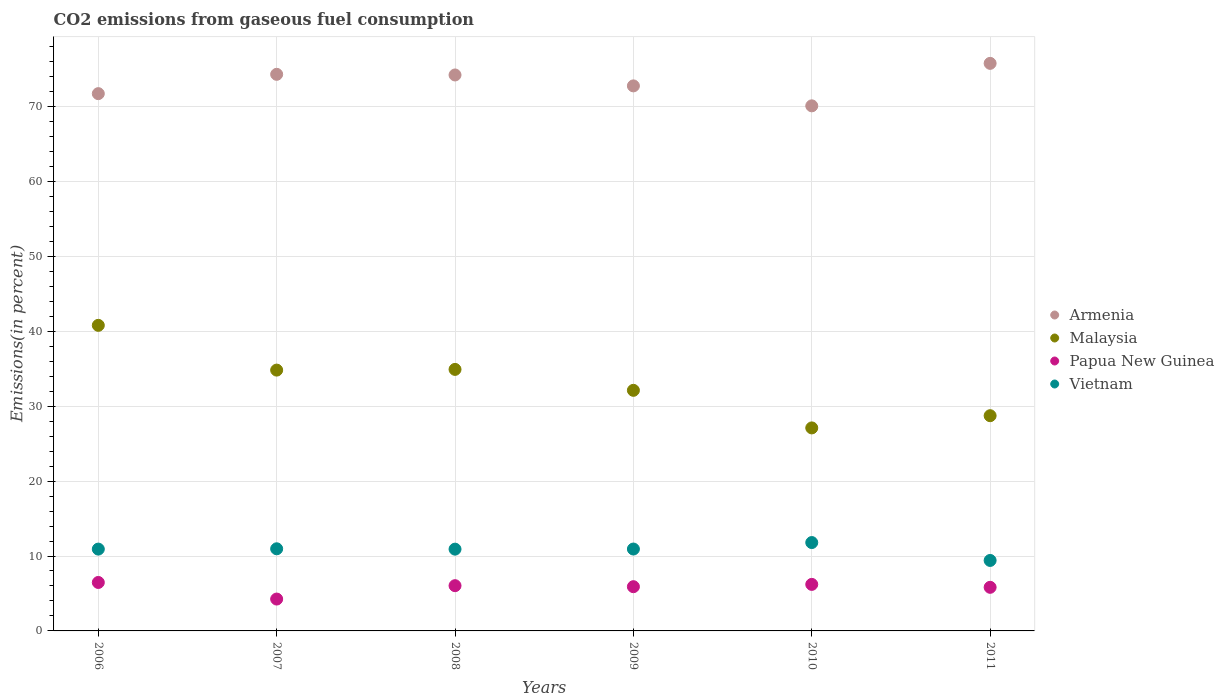Is the number of dotlines equal to the number of legend labels?
Ensure brevity in your answer.  Yes. What is the total CO2 emitted in Armenia in 2009?
Offer a very short reply. 72.75. Across all years, what is the maximum total CO2 emitted in Vietnam?
Your answer should be compact. 11.79. Across all years, what is the minimum total CO2 emitted in Vietnam?
Offer a very short reply. 9.41. What is the total total CO2 emitted in Vietnam in the graph?
Provide a succinct answer. 64.93. What is the difference between the total CO2 emitted in Vietnam in 2010 and that in 2011?
Your answer should be compact. 2.39. What is the difference between the total CO2 emitted in Vietnam in 2007 and the total CO2 emitted in Papua New Guinea in 2008?
Provide a short and direct response. 4.92. What is the average total CO2 emitted in Vietnam per year?
Your response must be concise. 10.82. In the year 2011, what is the difference between the total CO2 emitted in Vietnam and total CO2 emitted in Armenia?
Provide a succinct answer. -66.35. What is the ratio of the total CO2 emitted in Papua New Guinea in 2010 to that in 2011?
Your answer should be very brief. 1.07. Is the difference between the total CO2 emitted in Vietnam in 2006 and 2011 greater than the difference between the total CO2 emitted in Armenia in 2006 and 2011?
Give a very brief answer. Yes. What is the difference between the highest and the second highest total CO2 emitted in Armenia?
Ensure brevity in your answer.  1.46. What is the difference between the highest and the lowest total CO2 emitted in Papua New Guinea?
Provide a short and direct response. 2.21. Is the sum of the total CO2 emitted in Papua New Guinea in 2006 and 2009 greater than the maximum total CO2 emitted in Malaysia across all years?
Provide a short and direct response. No. Is it the case that in every year, the sum of the total CO2 emitted in Papua New Guinea and total CO2 emitted in Armenia  is greater than the total CO2 emitted in Vietnam?
Your answer should be compact. Yes. Does the total CO2 emitted in Armenia monotonically increase over the years?
Provide a succinct answer. No. Is the total CO2 emitted in Papua New Guinea strictly less than the total CO2 emitted in Vietnam over the years?
Offer a very short reply. Yes. How many years are there in the graph?
Give a very brief answer. 6. What is the difference between two consecutive major ticks on the Y-axis?
Offer a very short reply. 10. Does the graph contain any zero values?
Keep it short and to the point. No. How many legend labels are there?
Your answer should be compact. 4. What is the title of the graph?
Keep it short and to the point. CO2 emissions from gaseous fuel consumption. Does "Low income" appear as one of the legend labels in the graph?
Give a very brief answer. No. What is the label or title of the Y-axis?
Make the answer very short. Emissions(in percent). What is the Emissions(in percent) of Armenia in 2006?
Your answer should be compact. 71.72. What is the Emissions(in percent) in Malaysia in 2006?
Your answer should be compact. 40.79. What is the Emissions(in percent) in Papua New Guinea in 2006?
Your answer should be compact. 6.47. What is the Emissions(in percent) of Vietnam in 2006?
Give a very brief answer. 10.92. What is the Emissions(in percent) of Armenia in 2007?
Keep it short and to the point. 74.29. What is the Emissions(in percent) in Malaysia in 2007?
Provide a succinct answer. 34.81. What is the Emissions(in percent) of Papua New Guinea in 2007?
Provide a short and direct response. 4.25. What is the Emissions(in percent) of Vietnam in 2007?
Your answer should be compact. 10.96. What is the Emissions(in percent) of Armenia in 2008?
Your response must be concise. 74.21. What is the Emissions(in percent) in Malaysia in 2008?
Provide a succinct answer. 34.91. What is the Emissions(in percent) of Papua New Guinea in 2008?
Keep it short and to the point. 6.04. What is the Emissions(in percent) of Vietnam in 2008?
Offer a terse response. 10.91. What is the Emissions(in percent) of Armenia in 2009?
Ensure brevity in your answer.  72.75. What is the Emissions(in percent) of Malaysia in 2009?
Give a very brief answer. 32.11. What is the Emissions(in percent) of Papua New Guinea in 2009?
Give a very brief answer. 5.9. What is the Emissions(in percent) in Vietnam in 2009?
Keep it short and to the point. 10.93. What is the Emissions(in percent) in Armenia in 2010?
Offer a very short reply. 70.09. What is the Emissions(in percent) in Malaysia in 2010?
Offer a very short reply. 27.1. What is the Emissions(in percent) of Papua New Guinea in 2010?
Make the answer very short. 6.21. What is the Emissions(in percent) in Vietnam in 2010?
Your answer should be very brief. 11.79. What is the Emissions(in percent) of Armenia in 2011?
Your response must be concise. 75.76. What is the Emissions(in percent) in Malaysia in 2011?
Your answer should be compact. 28.73. What is the Emissions(in percent) of Papua New Guinea in 2011?
Offer a terse response. 5.82. What is the Emissions(in percent) of Vietnam in 2011?
Your response must be concise. 9.41. Across all years, what is the maximum Emissions(in percent) in Armenia?
Your answer should be compact. 75.76. Across all years, what is the maximum Emissions(in percent) of Malaysia?
Your answer should be very brief. 40.79. Across all years, what is the maximum Emissions(in percent) in Papua New Guinea?
Give a very brief answer. 6.47. Across all years, what is the maximum Emissions(in percent) in Vietnam?
Make the answer very short. 11.79. Across all years, what is the minimum Emissions(in percent) in Armenia?
Your answer should be very brief. 70.09. Across all years, what is the minimum Emissions(in percent) of Malaysia?
Provide a succinct answer. 27.1. Across all years, what is the minimum Emissions(in percent) in Papua New Guinea?
Give a very brief answer. 4.25. Across all years, what is the minimum Emissions(in percent) of Vietnam?
Keep it short and to the point. 9.41. What is the total Emissions(in percent) in Armenia in the graph?
Your response must be concise. 438.81. What is the total Emissions(in percent) of Malaysia in the graph?
Your answer should be very brief. 198.45. What is the total Emissions(in percent) of Papua New Guinea in the graph?
Give a very brief answer. 34.7. What is the total Emissions(in percent) in Vietnam in the graph?
Offer a very short reply. 64.93. What is the difference between the Emissions(in percent) of Armenia in 2006 and that in 2007?
Provide a succinct answer. -2.58. What is the difference between the Emissions(in percent) in Malaysia in 2006 and that in 2007?
Your response must be concise. 5.97. What is the difference between the Emissions(in percent) of Papua New Guinea in 2006 and that in 2007?
Make the answer very short. 2.21. What is the difference between the Emissions(in percent) of Vietnam in 2006 and that in 2007?
Your answer should be compact. -0.04. What is the difference between the Emissions(in percent) of Armenia in 2006 and that in 2008?
Provide a short and direct response. -2.49. What is the difference between the Emissions(in percent) in Malaysia in 2006 and that in 2008?
Provide a succinct answer. 5.88. What is the difference between the Emissions(in percent) of Papua New Guinea in 2006 and that in 2008?
Offer a terse response. 0.43. What is the difference between the Emissions(in percent) of Vietnam in 2006 and that in 2008?
Provide a succinct answer. 0.01. What is the difference between the Emissions(in percent) in Armenia in 2006 and that in 2009?
Offer a very short reply. -1.03. What is the difference between the Emissions(in percent) in Malaysia in 2006 and that in 2009?
Your answer should be compact. 8.67. What is the difference between the Emissions(in percent) of Papua New Guinea in 2006 and that in 2009?
Provide a short and direct response. 0.56. What is the difference between the Emissions(in percent) in Vietnam in 2006 and that in 2009?
Your answer should be compact. -0.01. What is the difference between the Emissions(in percent) of Armenia in 2006 and that in 2010?
Provide a succinct answer. 1.63. What is the difference between the Emissions(in percent) in Malaysia in 2006 and that in 2010?
Keep it short and to the point. 13.69. What is the difference between the Emissions(in percent) in Papua New Guinea in 2006 and that in 2010?
Offer a terse response. 0.26. What is the difference between the Emissions(in percent) in Vietnam in 2006 and that in 2010?
Offer a terse response. -0.87. What is the difference between the Emissions(in percent) of Armenia in 2006 and that in 2011?
Offer a very short reply. -4.04. What is the difference between the Emissions(in percent) in Malaysia in 2006 and that in 2011?
Your answer should be very brief. 12.06. What is the difference between the Emissions(in percent) of Papua New Guinea in 2006 and that in 2011?
Offer a terse response. 0.65. What is the difference between the Emissions(in percent) of Vietnam in 2006 and that in 2011?
Your answer should be compact. 1.51. What is the difference between the Emissions(in percent) of Armenia in 2007 and that in 2008?
Make the answer very short. 0.09. What is the difference between the Emissions(in percent) in Malaysia in 2007 and that in 2008?
Make the answer very short. -0.09. What is the difference between the Emissions(in percent) of Papua New Guinea in 2007 and that in 2008?
Offer a very short reply. -1.79. What is the difference between the Emissions(in percent) in Vietnam in 2007 and that in 2008?
Give a very brief answer. 0.05. What is the difference between the Emissions(in percent) in Armenia in 2007 and that in 2009?
Offer a very short reply. 1.54. What is the difference between the Emissions(in percent) in Malaysia in 2007 and that in 2009?
Your answer should be very brief. 2.7. What is the difference between the Emissions(in percent) in Papua New Guinea in 2007 and that in 2009?
Offer a terse response. -1.65. What is the difference between the Emissions(in percent) in Vietnam in 2007 and that in 2009?
Provide a succinct answer. 0.03. What is the difference between the Emissions(in percent) of Armenia in 2007 and that in 2010?
Your answer should be very brief. 4.21. What is the difference between the Emissions(in percent) of Malaysia in 2007 and that in 2010?
Provide a succinct answer. 7.72. What is the difference between the Emissions(in percent) in Papua New Guinea in 2007 and that in 2010?
Provide a short and direct response. -1.96. What is the difference between the Emissions(in percent) in Vietnam in 2007 and that in 2010?
Make the answer very short. -0.83. What is the difference between the Emissions(in percent) in Armenia in 2007 and that in 2011?
Your answer should be very brief. -1.46. What is the difference between the Emissions(in percent) of Malaysia in 2007 and that in 2011?
Your answer should be compact. 6.09. What is the difference between the Emissions(in percent) of Papua New Guinea in 2007 and that in 2011?
Your answer should be very brief. -1.57. What is the difference between the Emissions(in percent) of Vietnam in 2007 and that in 2011?
Give a very brief answer. 1.56. What is the difference between the Emissions(in percent) in Armenia in 2008 and that in 2009?
Keep it short and to the point. 1.46. What is the difference between the Emissions(in percent) in Malaysia in 2008 and that in 2009?
Keep it short and to the point. 2.79. What is the difference between the Emissions(in percent) in Papua New Guinea in 2008 and that in 2009?
Make the answer very short. 0.14. What is the difference between the Emissions(in percent) of Vietnam in 2008 and that in 2009?
Make the answer very short. -0.02. What is the difference between the Emissions(in percent) of Armenia in 2008 and that in 2010?
Give a very brief answer. 4.12. What is the difference between the Emissions(in percent) of Malaysia in 2008 and that in 2010?
Offer a terse response. 7.81. What is the difference between the Emissions(in percent) of Papua New Guinea in 2008 and that in 2010?
Your answer should be very brief. -0.17. What is the difference between the Emissions(in percent) in Vietnam in 2008 and that in 2010?
Offer a very short reply. -0.88. What is the difference between the Emissions(in percent) of Armenia in 2008 and that in 2011?
Keep it short and to the point. -1.55. What is the difference between the Emissions(in percent) of Malaysia in 2008 and that in 2011?
Keep it short and to the point. 6.18. What is the difference between the Emissions(in percent) in Papua New Guinea in 2008 and that in 2011?
Offer a very short reply. 0.22. What is the difference between the Emissions(in percent) of Vietnam in 2008 and that in 2011?
Ensure brevity in your answer.  1.51. What is the difference between the Emissions(in percent) in Armenia in 2009 and that in 2010?
Your answer should be compact. 2.66. What is the difference between the Emissions(in percent) of Malaysia in 2009 and that in 2010?
Ensure brevity in your answer.  5.02. What is the difference between the Emissions(in percent) of Papua New Guinea in 2009 and that in 2010?
Offer a terse response. -0.31. What is the difference between the Emissions(in percent) of Vietnam in 2009 and that in 2010?
Provide a short and direct response. -0.86. What is the difference between the Emissions(in percent) of Armenia in 2009 and that in 2011?
Give a very brief answer. -3.01. What is the difference between the Emissions(in percent) of Malaysia in 2009 and that in 2011?
Make the answer very short. 3.39. What is the difference between the Emissions(in percent) in Papua New Guinea in 2009 and that in 2011?
Your answer should be very brief. 0.08. What is the difference between the Emissions(in percent) of Vietnam in 2009 and that in 2011?
Ensure brevity in your answer.  1.52. What is the difference between the Emissions(in percent) of Armenia in 2010 and that in 2011?
Ensure brevity in your answer.  -5.67. What is the difference between the Emissions(in percent) of Malaysia in 2010 and that in 2011?
Keep it short and to the point. -1.63. What is the difference between the Emissions(in percent) of Papua New Guinea in 2010 and that in 2011?
Your answer should be compact. 0.39. What is the difference between the Emissions(in percent) in Vietnam in 2010 and that in 2011?
Provide a succinct answer. 2.39. What is the difference between the Emissions(in percent) in Armenia in 2006 and the Emissions(in percent) in Malaysia in 2007?
Provide a short and direct response. 36.9. What is the difference between the Emissions(in percent) of Armenia in 2006 and the Emissions(in percent) of Papua New Guinea in 2007?
Your answer should be very brief. 67.46. What is the difference between the Emissions(in percent) in Armenia in 2006 and the Emissions(in percent) in Vietnam in 2007?
Provide a succinct answer. 60.75. What is the difference between the Emissions(in percent) in Malaysia in 2006 and the Emissions(in percent) in Papua New Guinea in 2007?
Your response must be concise. 36.53. What is the difference between the Emissions(in percent) in Malaysia in 2006 and the Emissions(in percent) in Vietnam in 2007?
Provide a short and direct response. 29.83. What is the difference between the Emissions(in percent) in Papua New Guinea in 2006 and the Emissions(in percent) in Vietnam in 2007?
Your answer should be compact. -4.49. What is the difference between the Emissions(in percent) of Armenia in 2006 and the Emissions(in percent) of Malaysia in 2008?
Give a very brief answer. 36.81. What is the difference between the Emissions(in percent) of Armenia in 2006 and the Emissions(in percent) of Papua New Guinea in 2008?
Offer a very short reply. 65.68. What is the difference between the Emissions(in percent) in Armenia in 2006 and the Emissions(in percent) in Vietnam in 2008?
Keep it short and to the point. 60.8. What is the difference between the Emissions(in percent) in Malaysia in 2006 and the Emissions(in percent) in Papua New Guinea in 2008?
Offer a terse response. 34.75. What is the difference between the Emissions(in percent) of Malaysia in 2006 and the Emissions(in percent) of Vietnam in 2008?
Provide a succinct answer. 29.87. What is the difference between the Emissions(in percent) of Papua New Guinea in 2006 and the Emissions(in percent) of Vietnam in 2008?
Give a very brief answer. -4.45. What is the difference between the Emissions(in percent) in Armenia in 2006 and the Emissions(in percent) in Malaysia in 2009?
Offer a very short reply. 39.6. What is the difference between the Emissions(in percent) of Armenia in 2006 and the Emissions(in percent) of Papua New Guinea in 2009?
Your response must be concise. 65.81. What is the difference between the Emissions(in percent) in Armenia in 2006 and the Emissions(in percent) in Vietnam in 2009?
Your response must be concise. 60.78. What is the difference between the Emissions(in percent) of Malaysia in 2006 and the Emissions(in percent) of Papua New Guinea in 2009?
Offer a terse response. 34.88. What is the difference between the Emissions(in percent) in Malaysia in 2006 and the Emissions(in percent) in Vietnam in 2009?
Make the answer very short. 29.86. What is the difference between the Emissions(in percent) in Papua New Guinea in 2006 and the Emissions(in percent) in Vietnam in 2009?
Ensure brevity in your answer.  -4.46. What is the difference between the Emissions(in percent) in Armenia in 2006 and the Emissions(in percent) in Malaysia in 2010?
Offer a very short reply. 44.62. What is the difference between the Emissions(in percent) in Armenia in 2006 and the Emissions(in percent) in Papua New Guinea in 2010?
Ensure brevity in your answer.  65.5. What is the difference between the Emissions(in percent) in Armenia in 2006 and the Emissions(in percent) in Vietnam in 2010?
Your answer should be very brief. 59.92. What is the difference between the Emissions(in percent) in Malaysia in 2006 and the Emissions(in percent) in Papua New Guinea in 2010?
Provide a succinct answer. 34.58. What is the difference between the Emissions(in percent) of Malaysia in 2006 and the Emissions(in percent) of Vietnam in 2010?
Your answer should be very brief. 28.99. What is the difference between the Emissions(in percent) of Papua New Guinea in 2006 and the Emissions(in percent) of Vietnam in 2010?
Provide a succinct answer. -5.33. What is the difference between the Emissions(in percent) in Armenia in 2006 and the Emissions(in percent) in Malaysia in 2011?
Keep it short and to the point. 42.99. What is the difference between the Emissions(in percent) in Armenia in 2006 and the Emissions(in percent) in Papua New Guinea in 2011?
Provide a succinct answer. 65.89. What is the difference between the Emissions(in percent) of Armenia in 2006 and the Emissions(in percent) of Vietnam in 2011?
Give a very brief answer. 62.31. What is the difference between the Emissions(in percent) of Malaysia in 2006 and the Emissions(in percent) of Papua New Guinea in 2011?
Provide a short and direct response. 34.97. What is the difference between the Emissions(in percent) in Malaysia in 2006 and the Emissions(in percent) in Vietnam in 2011?
Your answer should be compact. 31.38. What is the difference between the Emissions(in percent) of Papua New Guinea in 2006 and the Emissions(in percent) of Vietnam in 2011?
Offer a very short reply. -2.94. What is the difference between the Emissions(in percent) of Armenia in 2007 and the Emissions(in percent) of Malaysia in 2008?
Keep it short and to the point. 39.39. What is the difference between the Emissions(in percent) of Armenia in 2007 and the Emissions(in percent) of Papua New Guinea in 2008?
Your response must be concise. 68.25. What is the difference between the Emissions(in percent) in Armenia in 2007 and the Emissions(in percent) in Vietnam in 2008?
Provide a short and direct response. 63.38. What is the difference between the Emissions(in percent) in Malaysia in 2007 and the Emissions(in percent) in Papua New Guinea in 2008?
Your answer should be very brief. 28.77. What is the difference between the Emissions(in percent) in Malaysia in 2007 and the Emissions(in percent) in Vietnam in 2008?
Offer a very short reply. 23.9. What is the difference between the Emissions(in percent) in Papua New Guinea in 2007 and the Emissions(in percent) in Vietnam in 2008?
Your response must be concise. -6.66. What is the difference between the Emissions(in percent) of Armenia in 2007 and the Emissions(in percent) of Malaysia in 2009?
Your answer should be very brief. 42.18. What is the difference between the Emissions(in percent) in Armenia in 2007 and the Emissions(in percent) in Papua New Guinea in 2009?
Give a very brief answer. 68.39. What is the difference between the Emissions(in percent) of Armenia in 2007 and the Emissions(in percent) of Vietnam in 2009?
Offer a terse response. 63.36. What is the difference between the Emissions(in percent) in Malaysia in 2007 and the Emissions(in percent) in Papua New Guinea in 2009?
Make the answer very short. 28.91. What is the difference between the Emissions(in percent) of Malaysia in 2007 and the Emissions(in percent) of Vietnam in 2009?
Keep it short and to the point. 23.88. What is the difference between the Emissions(in percent) in Papua New Guinea in 2007 and the Emissions(in percent) in Vietnam in 2009?
Provide a short and direct response. -6.68. What is the difference between the Emissions(in percent) of Armenia in 2007 and the Emissions(in percent) of Malaysia in 2010?
Your answer should be very brief. 47.2. What is the difference between the Emissions(in percent) in Armenia in 2007 and the Emissions(in percent) in Papua New Guinea in 2010?
Ensure brevity in your answer.  68.08. What is the difference between the Emissions(in percent) of Armenia in 2007 and the Emissions(in percent) of Vietnam in 2010?
Ensure brevity in your answer.  62.5. What is the difference between the Emissions(in percent) of Malaysia in 2007 and the Emissions(in percent) of Papua New Guinea in 2010?
Provide a succinct answer. 28.6. What is the difference between the Emissions(in percent) in Malaysia in 2007 and the Emissions(in percent) in Vietnam in 2010?
Provide a succinct answer. 23.02. What is the difference between the Emissions(in percent) in Papua New Guinea in 2007 and the Emissions(in percent) in Vietnam in 2010?
Offer a very short reply. -7.54. What is the difference between the Emissions(in percent) of Armenia in 2007 and the Emissions(in percent) of Malaysia in 2011?
Make the answer very short. 45.57. What is the difference between the Emissions(in percent) of Armenia in 2007 and the Emissions(in percent) of Papua New Guinea in 2011?
Your response must be concise. 68.47. What is the difference between the Emissions(in percent) of Armenia in 2007 and the Emissions(in percent) of Vietnam in 2011?
Give a very brief answer. 64.89. What is the difference between the Emissions(in percent) of Malaysia in 2007 and the Emissions(in percent) of Papua New Guinea in 2011?
Provide a succinct answer. 28.99. What is the difference between the Emissions(in percent) in Malaysia in 2007 and the Emissions(in percent) in Vietnam in 2011?
Provide a succinct answer. 25.41. What is the difference between the Emissions(in percent) in Papua New Guinea in 2007 and the Emissions(in percent) in Vietnam in 2011?
Offer a very short reply. -5.15. What is the difference between the Emissions(in percent) of Armenia in 2008 and the Emissions(in percent) of Malaysia in 2009?
Give a very brief answer. 42.09. What is the difference between the Emissions(in percent) in Armenia in 2008 and the Emissions(in percent) in Papua New Guinea in 2009?
Offer a very short reply. 68.3. What is the difference between the Emissions(in percent) of Armenia in 2008 and the Emissions(in percent) of Vietnam in 2009?
Your response must be concise. 63.28. What is the difference between the Emissions(in percent) in Malaysia in 2008 and the Emissions(in percent) in Papua New Guinea in 2009?
Give a very brief answer. 29. What is the difference between the Emissions(in percent) in Malaysia in 2008 and the Emissions(in percent) in Vietnam in 2009?
Your answer should be very brief. 23.98. What is the difference between the Emissions(in percent) of Papua New Guinea in 2008 and the Emissions(in percent) of Vietnam in 2009?
Your answer should be very brief. -4.89. What is the difference between the Emissions(in percent) of Armenia in 2008 and the Emissions(in percent) of Malaysia in 2010?
Your response must be concise. 47.11. What is the difference between the Emissions(in percent) of Armenia in 2008 and the Emissions(in percent) of Papua New Guinea in 2010?
Your answer should be compact. 68. What is the difference between the Emissions(in percent) in Armenia in 2008 and the Emissions(in percent) in Vietnam in 2010?
Offer a terse response. 62.41. What is the difference between the Emissions(in percent) in Malaysia in 2008 and the Emissions(in percent) in Papua New Guinea in 2010?
Your answer should be compact. 28.7. What is the difference between the Emissions(in percent) in Malaysia in 2008 and the Emissions(in percent) in Vietnam in 2010?
Your response must be concise. 23.11. What is the difference between the Emissions(in percent) in Papua New Guinea in 2008 and the Emissions(in percent) in Vietnam in 2010?
Keep it short and to the point. -5.76. What is the difference between the Emissions(in percent) in Armenia in 2008 and the Emissions(in percent) in Malaysia in 2011?
Your response must be concise. 45.48. What is the difference between the Emissions(in percent) in Armenia in 2008 and the Emissions(in percent) in Papua New Guinea in 2011?
Your answer should be compact. 68.39. What is the difference between the Emissions(in percent) in Armenia in 2008 and the Emissions(in percent) in Vietnam in 2011?
Your response must be concise. 64.8. What is the difference between the Emissions(in percent) in Malaysia in 2008 and the Emissions(in percent) in Papua New Guinea in 2011?
Your response must be concise. 29.09. What is the difference between the Emissions(in percent) in Malaysia in 2008 and the Emissions(in percent) in Vietnam in 2011?
Give a very brief answer. 25.5. What is the difference between the Emissions(in percent) in Papua New Guinea in 2008 and the Emissions(in percent) in Vietnam in 2011?
Your answer should be compact. -3.37. What is the difference between the Emissions(in percent) of Armenia in 2009 and the Emissions(in percent) of Malaysia in 2010?
Offer a very short reply. 45.65. What is the difference between the Emissions(in percent) in Armenia in 2009 and the Emissions(in percent) in Papua New Guinea in 2010?
Provide a short and direct response. 66.54. What is the difference between the Emissions(in percent) in Armenia in 2009 and the Emissions(in percent) in Vietnam in 2010?
Offer a very short reply. 60.96. What is the difference between the Emissions(in percent) in Malaysia in 2009 and the Emissions(in percent) in Papua New Guinea in 2010?
Your answer should be compact. 25.9. What is the difference between the Emissions(in percent) of Malaysia in 2009 and the Emissions(in percent) of Vietnam in 2010?
Your answer should be very brief. 20.32. What is the difference between the Emissions(in percent) of Papua New Guinea in 2009 and the Emissions(in percent) of Vietnam in 2010?
Offer a terse response. -5.89. What is the difference between the Emissions(in percent) in Armenia in 2009 and the Emissions(in percent) in Malaysia in 2011?
Make the answer very short. 44.02. What is the difference between the Emissions(in percent) in Armenia in 2009 and the Emissions(in percent) in Papua New Guinea in 2011?
Your answer should be very brief. 66.93. What is the difference between the Emissions(in percent) in Armenia in 2009 and the Emissions(in percent) in Vietnam in 2011?
Offer a terse response. 63.34. What is the difference between the Emissions(in percent) of Malaysia in 2009 and the Emissions(in percent) of Papua New Guinea in 2011?
Your response must be concise. 26.29. What is the difference between the Emissions(in percent) in Malaysia in 2009 and the Emissions(in percent) in Vietnam in 2011?
Offer a very short reply. 22.71. What is the difference between the Emissions(in percent) in Papua New Guinea in 2009 and the Emissions(in percent) in Vietnam in 2011?
Provide a succinct answer. -3.5. What is the difference between the Emissions(in percent) in Armenia in 2010 and the Emissions(in percent) in Malaysia in 2011?
Provide a short and direct response. 41.36. What is the difference between the Emissions(in percent) in Armenia in 2010 and the Emissions(in percent) in Papua New Guinea in 2011?
Your answer should be very brief. 64.27. What is the difference between the Emissions(in percent) in Armenia in 2010 and the Emissions(in percent) in Vietnam in 2011?
Offer a terse response. 60.68. What is the difference between the Emissions(in percent) in Malaysia in 2010 and the Emissions(in percent) in Papua New Guinea in 2011?
Ensure brevity in your answer.  21.28. What is the difference between the Emissions(in percent) of Malaysia in 2010 and the Emissions(in percent) of Vietnam in 2011?
Give a very brief answer. 17.69. What is the difference between the Emissions(in percent) of Papua New Guinea in 2010 and the Emissions(in percent) of Vietnam in 2011?
Provide a short and direct response. -3.2. What is the average Emissions(in percent) of Armenia per year?
Offer a terse response. 73.14. What is the average Emissions(in percent) in Malaysia per year?
Provide a succinct answer. 33.07. What is the average Emissions(in percent) of Papua New Guinea per year?
Your answer should be compact. 5.78. What is the average Emissions(in percent) in Vietnam per year?
Offer a very short reply. 10.82. In the year 2006, what is the difference between the Emissions(in percent) in Armenia and Emissions(in percent) in Malaysia?
Ensure brevity in your answer.  30.93. In the year 2006, what is the difference between the Emissions(in percent) of Armenia and Emissions(in percent) of Papua New Guinea?
Provide a succinct answer. 65.25. In the year 2006, what is the difference between the Emissions(in percent) in Armenia and Emissions(in percent) in Vietnam?
Keep it short and to the point. 60.79. In the year 2006, what is the difference between the Emissions(in percent) in Malaysia and Emissions(in percent) in Papua New Guinea?
Make the answer very short. 34.32. In the year 2006, what is the difference between the Emissions(in percent) in Malaysia and Emissions(in percent) in Vietnam?
Your answer should be compact. 29.87. In the year 2006, what is the difference between the Emissions(in percent) of Papua New Guinea and Emissions(in percent) of Vietnam?
Your response must be concise. -4.45. In the year 2007, what is the difference between the Emissions(in percent) in Armenia and Emissions(in percent) in Malaysia?
Your answer should be compact. 39.48. In the year 2007, what is the difference between the Emissions(in percent) in Armenia and Emissions(in percent) in Papua New Guinea?
Provide a succinct answer. 70.04. In the year 2007, what is the difference between the Emissions(in percent) in Armenia and Emissions(in percent) in Vietnam?
Your response must be concise. 63.33. In the year 2007, what is the difference between the Emissions(in percent) in Malaysia and Emissions(in percent) in Papua New Guinea?
Your response must be concise. 30.56. In the year 2007, what is the difference between the Emissions(in percent) in Malaysia and Emissions(in percent) in Vietnam?
Offer a terse response. 23.85. In the year 2007, what is the difference between the Emissions(in percent) of Papua New Guinea and Emissions(in percent) of Vietnam?
Offer a terse response. -6.71. In the year 2008, what is the difference between the Emissions(in percent) of Armenia and Emissions(in percent) of Malaysia?
Provide a short and direct response. 39.3. In the year 2008, what is the difference between the Emissions(in percent) in Armenia and Emissions(in percent) in Papua New Guinea?
Your response must be concise. 68.17. In the year 2008, what is the difference between the Emissions(in percent) of Armenia and Emissions(in percent) of Vietnam?
Give a very brief answer. 63.29. In the year 2008, what is the difference between the Emissions(in percent) in Malaysia and Emissions(in percent) in Papua New Guinea?
Keep it short and to the point. 28.87. In the year 2008, what is the difference between the Emissions(in percent) of Malaysia and Emissions(in percent) of Vietnam?
Provide a succinct answer. 23.99. In the year 2008, what is the difference between the Emissions(in percent) of Papua New Guinea and Emissions(in percent) of Vietnam?
Offer a terse response. -4.88. In the year 2009, what is the difference between the Emissions(in percent) of Armenia and Emissions(in percent) of Malaysia?
Offer a very short reply. 40.64. In the year 2009, what is the difference between the Emissions(in percent) in Armenia and Emissions(in percent) in Papua New Guinea?
Offer a very short reply. 66.85. In the year 2009, what is the difference between the Emissions(in percent) of Armenia and Emissions(in percent) of Vietnam?
Offer a very short reply. 61.82. In the year 2009, what is the difference between the Emissions(in percent) in Malaysia and Emissions(in percent) in Papua New Guinea?
Offer a terse response. 26.21. In the year 2009, what is the difference between the Emissions(in percent) in Malaysia and Emissions(in percent) in Vietnam?
Provide a succinct answer. 21.18. In the year 2009, what is the difference between the Emissions(in percent) of Papua New Guinea and Emissions(in percent) of Vietnam?
Make the answer very short. -5.03. In the year 2010, what is the difference between the Emissions(in percent) of Armenia and Emissions(in percent) of Malaysia?
Make the answer very short. 42.99. In the year 2010, what is the difference between the Emissions(in percent) of Armenia and Emissions(in percent) of Papua New Guinea?
Offer a terse response. 63.88. In the year 2010, what is the difference between the Emissions(in percent) of Armenia and Emissions(in percent) of Vietnam?
Ensure brevity in your answer.  58.29. In the year 2010, what is the difference between the Emissions(in percent) in Malaysia and Emissions(in percent) in Papua New Guinea?
Make the answer very short. 20.89. In the year 2010, what is the difference between the Emissions(in percent) in Malaysia and Emissions(in percent) in Vietnam?
Provide a short and direct response. 15.3. In the year 2010, what is the difference between the Emissions(in percent) in Papua New Guinea and Emissions(in percent) in Vietnam?
Provide a short and direct response. -5.58. In the year 2011, what is the difference between the Emissions(in percent) in Armenia and Emissions(in percent) in Malaysia?
Provide a short and direct response. 47.03. In the year 2011, what is the difference between the Emissions(in percent) of Armenia and Emissions(in percent) of Papua New Guinea?
Make the answer very short. 69.94. In the year 2011, what is the difference between the Emissions(in percent) in Armenia and Emissions(in percent) in Vietnam?
Make the answer very short. 66.35. In the year 2011, what is the difference between the Emissions(in percent) of Malaysia and Emissions(in percent) of Papua New Guinea?
Your answer should be very brief. 22.91. In the year 2011, what is the difference between the Emissions(in percent) in Malaysia and Emissions(in percent) in Vietnam?
Ensure brevity in your answer.  19.32. In the year 2011, what is the difference between the Emissions(in percent) in Papua New Guinea and Emissions(in percent) in Vietnam?
Offer a very short reply. -3.59. What is the ratio of the Emissions(in percent) in Armenia in 2006 to that in 2007?
Make the answer very short. 0.97. What is the ratio of the Emissions(in percent) in Malaysia in 2006 to that in 2007?
Your answer should be compact. 1.17. What is the ratio of the Emissions(in percent) in Papua New Guinea in 2006 to that in 2007?
Give a very brief answer. 1.52. What is the ratio of the Emissions(in percent) of Vietnam in 2006 to that in 2007?
Your response must be concise. 1. What is the ratio of the Emissions(in percent) of Armenia in 2006 to that in 2008?
Provide a short and direct response. 0.97. What is the ratio of the Emissions(in percent) of Malaysia in 2006 to that in 2008?
Your answer should be very brief. 1.17. What is the ratio of the Emissions(in percent) in Papua New Guinea in 2006 to that in 2008?
Your answer should be very brief. 1.07. What is the ratio of the Emissions(in percent) in Armenia in 2006 to that in 2009?
Your answer should be compact. 0.99. What is the ratio of the Emissions(in percent) in Malaysia in 2006 to that in 2009?
Offer a very short reply. 1.27. What is the ratio of the Emissions(in percent) of Papua New Guinea in 2006 to that in 2009?
Your answer should be compact. 1.1. What is the ratio of the Emissions(in percent) in Vietnam in 2006 to that in 2009?
Make the answer very short. 1. What is the ratio of the Emissions(in percent) in Armenia in 2006 to that in 2010?
Keep it short and to the point. 1.02. What is the ratio of the Emissions(in percent) of Malaysia in 2006 to that in 2010?
Your response must be concise. 1.51. What is the ratio of the Emissions(in percent) in Papua New Guinea in 2006 to that in 2010?
Make the answer very short. 1.04. What is the ratio of the Emissions(in percent) in Vietnam in 2006 to that in 2010?
Your answer should be compact. 0.93. What is the ratio of the Emissions(in percent) in Armenia in 2006 to that in 2011?
Your answer should be compact. 0.95. What is the ratio of the Emissions(in percent) in Malaysia in 2006 to that in 2011?
Ensure brevity in your answer.  1.42. What is the ratio of the Emissions(in percent) in Papua New Guinea in 2006 to that in 2011?
Provide a short and direct response. 1.11. What is the ratio of the Emissions(in percent) in Vietnam in 2006 to that in 2011?
Give a very brief answer. 1.16. What is the ratio of the Emissions(in percent) in Armenia in 2007 to that in 2008?
Offer a terse response. 1. What is the ratio of the Emissions(in percent) of Papua New Guinea in 2007 to that in 2008?
Provide a succinct answer. 0.7. What is the ratio of the Emissions(in percent) of Armenia in 2007 to that in 2009?
Ensure brevity in your answer.  1.02. What is the ratio of the Emissions(in percent) in Malaysia in 2007 to that in 2009?
Make the answer very short. 1.08. What is the ratio of the Emissions(in percent) in Papua New Guinea in 2007 to that in 2009?
Your answer should be very brief. 0.72. What is the ratio of the Emissions(in percent) of Vietnam in 2007 to that in 2009?
Your answer should be compact. 1. What is the ratio of the Emissions(in percent) in Armenia in 2007 to that in 2010?
Offer a terse response. 1.06. What is the ratio of the Emissions(in percent) in Malaysia in 2007 to that in 2010?
Offer a terse response. 1.28. What is the ratio of the Emissions(in percent) in Papua New Guinea in 2007 to that in 2010?
Provide a short and direct response. 0.69. What is the ratio of the Emissions(in percent) of Vietnam in 2007 to that in 2010?
Your response must be concise. 0.93. What is the ratio of the Emissions(in percent) of Armenia in 2007 to that in 2011?
Offer a terse response. 0.98. What is the ratio of the Emissions(in percent) of Malaysia in 2007 to that in 2011?
Ensure brevity in your answer.  1.21. What is the ratio of the Emissions(in percent) in Papua New Guinea in 2007 to that in 2011?
Provide a short and direct response. 0.73. What is the ratio of the Emissions(in percent) of Vietnam in 2007 to that in 2011?
Provide a succinct answer. 1.17. What is the ratio of the Emissions(in percent) of Malaysia in 2008 to that in 2009?
Give a very brief answer. 1.09. What is the ratio of the Emissions(in percent) of Papua New Guinea in 2008 to that in 2009?
Offer a terse response. 1.02. What is the ratio of the Emissions(in percent) of Armenia in 2008 to that in 2010?
Your response must be concise. 1.06. What is the ratio of the Emissions(in percent) in Malaysia in 2008 to that in 2010?
Ensure brevity in your answer.  1.29. What is the ratio of the Emissions(in percent) in Papua New Guinea in 2008 to that in 2010?
Your answer should be very brief. 0.97. What is the ratio of the Emissions(in percent) of Vietnam in 2008 to that in 2010?
Offer a terse response. 0.93. What is the ratio of the Emissions(in percent) of Armenia in 2008 to that in 2011?
Your answer should be compact. 0.98. What is the ratio of the Emissions(in percent) in Malaysia in 2008 to that in 2011?
Your response must be concise. 1.22. What is the ratio of the Emissions(in percent) in Papua New Guinea in 2008 to that in 2011?
Your response must be concise. 1.04. What is the ratio of the Emissions(in percent) of Vietnam in 2008 to that in 2011?
Your response must be concise. 1.16. What is the ratio of the Emissions(in percent) in Armenia in 2009 to that in 2010?
Ensure brevity in your answer.  1.04. What is the ratio of the Emissions(in percent) of Malaysia in 2009 to that in 2010?
Offer a terse response. 1.19. What is the ratio of the Emissions(in percent) in Papua New Guinea in 2009 to that in 2010?
Ensure brevity in your answer.  0.95. What is the ratio of the Emissions(in percent) in Vietnam in 2009 to that in 2010?
Your response must be concise. 0.93. What is the ratio of the Emissions(in percent) in Armenia in 2009 to that in 2011?
Your response must be concise. 0.96. What is the ratio of the Emissions(in percent) in Malaysia in 2009 to that in 2011?
Your answer should be very brief. 1.12. What is the ratio of the Emissions(in percent) of Papua New Guinea in 2009 to that in 2011?
Ensure brevity in your answer.  1.01. What is the ratio of the Emissions(in percent) of Vietnam in 2009 to that in 2011?
Ensure brevity in your answer.  1.16. What is the ratio of the Emissions(in percent) of Armenia in 2010 to that in 2011?
Make the answer very short. 0.93. What is the ratio of the Emissions(in percent) of Malaysia in 2010 to that in 2011?
Provide a succinct answer. 0.94. What is the ratio of the Emissions(in percent) of Papua New Guinea in 2010 to that in 2011?
Give a very brief answer. 1.07. What is the ratio of the Emissions(in percent) of Vietnam in 2010 to that in 2011?
Make the answer very short. 1.25. What is the difference between the highest and the second highest Emissions(in percent) of Armenia?
Offer a very short reply. 1.46. What is the difference between the highest and the second highest Emissions(in percent) in Malaysia?
Make the answer very short. 5.88. What is the difference between the highest and the second highest Emissions(in percent) in Papua New Guinea?
Your answer should be very brief. 0.26. What is the difference between the highest and the second highest Emissions(in percent) of Vietnam?
Provide a succinct answer. 0.83. What is the difference between the highest and the lowest Emissions(in percent) in Armenia?
Offer a terse response. 5.67. What is the difference between the highest and the lowest Emissions(in percent) of Malaysia?
Give a very brief answer. 13.69. What is the difference between the highest and the lowest Emissions(in percent) of Papua New Guinea?
Make the answer very short. 2.21. What is the difference between the highest and the lowest Emissions(in percent) of Vietnam?
Your response must be concise. 2.39. 